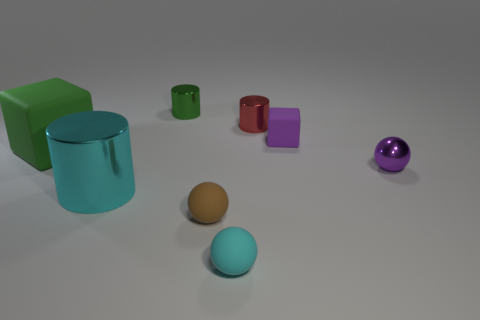Subtract all green balls. Subtract all yellow cubes. How many balls are left? 3 Add 2 brown shiny cylinders. How many objects exist? 10 Subtract all balls. How many objects are left? 5 Subtract 1 green cubes. How many objects are left? 7 Subtract all red objects. Subtract all tiny brown matte balls. How many objects are left? 6 Add 1 cylinders. How many cylinders are left? 4 Add 5 small purple matte things. How many small purple matte things exist? 6 